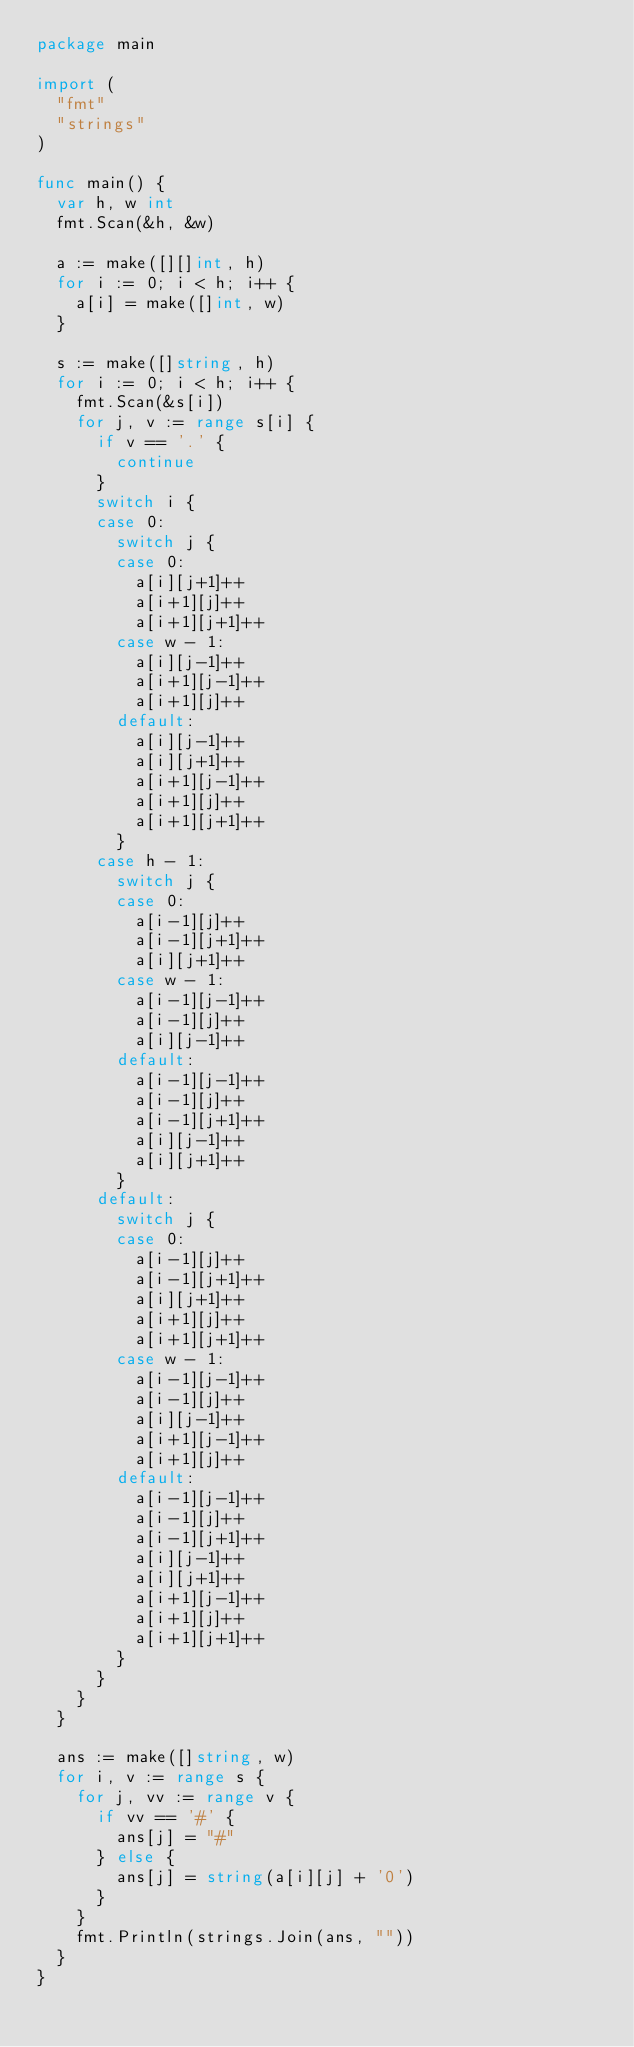Convert code to text. <code><loc_0><loc_0><loc_500><loc_500><_Go_>package main

import (
	"fmt"
	"strings"
)

func main() {
	var h, w int
	fmt.Scan(&h, &w)

	a := make([][]int, h)
	for i := 0; i < h; i++ {
		a[i] = make([]int, w)
	}

	s := make([]string, h)
	for i := 0; i < h; i++ {
		fmt.Scan(&s[i])
		for j, v := range s[i] {
			if v == '.' {
				continue
			}
			switch i {
			case 0:
				switch j {
				case 0:
					a[i][j+1]++
					a[i+1][j]++
					a[i+1][j+1]++
				case w - 1:
					a[i][j-1]++
					a[i+1][j-1]++
					a[i+1][j]++
				default:
					a[i][j-1]++
					a[i][j+1]++
					a[i+1][j-1]++
					a[i+1][j]++
					a[i+1][j+1]++
				}
			case h - 1:
				switch j {
				case 0:
					a[i-1][j]++
					a[i-1][j+1]++
					a[i][j+1]++
				case w - 1:
					a[i-1][j-1]++
					a[i-1][j]++
					a[i][j-1]++
				default:
					a[i-1][j-1]++
					a[i-1][j]++
					a[i-1][j+1]++
					a[i][j-1]++
					a[i][j+1]++
				}
			default:
				switch j {
				case 0:
					a[i-1][j]++
					a[i-1][j+1]++
					a[i][j+1]++
					a[i+1][j]++
					a[i+1][j+1]++
				case w - 1:
					a[i-1][j-1]++
					a[i-1][j]++
					a[i][j-1]++
					a[i+1][j-1]++
					a[i+1][j]++
				default:
					a[i-1][j-1]++
					a[i-1][j]++
					a[i-1][j+1]++
					a[i][j-1]++
					a[i][j+1]++
					a[i+1][j-1]++
					a[i+1][j]++
					a[i+1][j+1]++
				}
			}
		}
	}

	ans := make([]string, w)
	for i, v := range s {
		for j, vv := range v {
			if vv == '#' {
				ans[j] = "#"
			} else {
				ans[j] = string(a[i][j] + '0')
			}
		}
		fmt.Println(strings.Join(ans, ""))
	}
}
</code> 